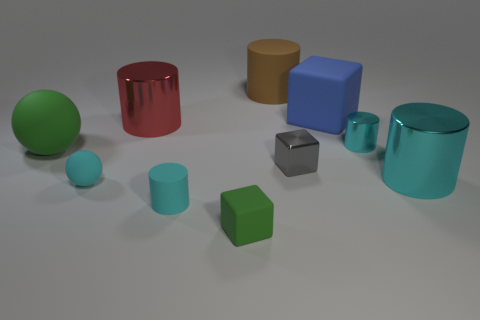There is a tiny matte ball; are there any small cyan things to the right of it?
Your response must be concise. Yes. How many things are either tiny red shiny objects or cyan metal things?
Ensure brevity in your answer.  2. What number of other objects are the same size as the metal block?
Ensure brevity in your answer.  4. What number of blocks are both right of the tiny green rubber object and in front of the large red metallic cylinder?
Make the answer very short. 1. Is the size of the green thing that is in front of the small gray metal object the same as the rubber cylinder that is left of the brown rubber thing?
Your answer should be compact. Yes. How big is the cylinder that is behind the blue block?
Make the answer very short. Large. How many objects are large things that are in front of the large brown cylinder or small things that are on the right side of the blue rubber cube?
Your answer should be very brief. 5. Are there any other things that have the same color as the big rubber cylinder?
Your response must be concise. No. Are there the same number of rubber cylinders behind the brown cylinder and cyan cylinders in front of the large green object?
Your answer should be very brief. No. Are there more big objects right of the large red cylinder than large green balls?
Make the answer very short. Yes. 